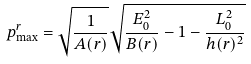Convert formula to latex. <formula><loc_0><loc_0><loc_500><loc_500>p ^ { r } _ { \max } = \sqrt { \frac { 1 } { A ( r ) } } \sqrt { \frac { E _ { 0 } ^ { 2 } } { B ( r ) } - 1 - \frac { L _ { 0 } ^ { 2 } } { h ( r ) ^ { 2 } } }</formula> 